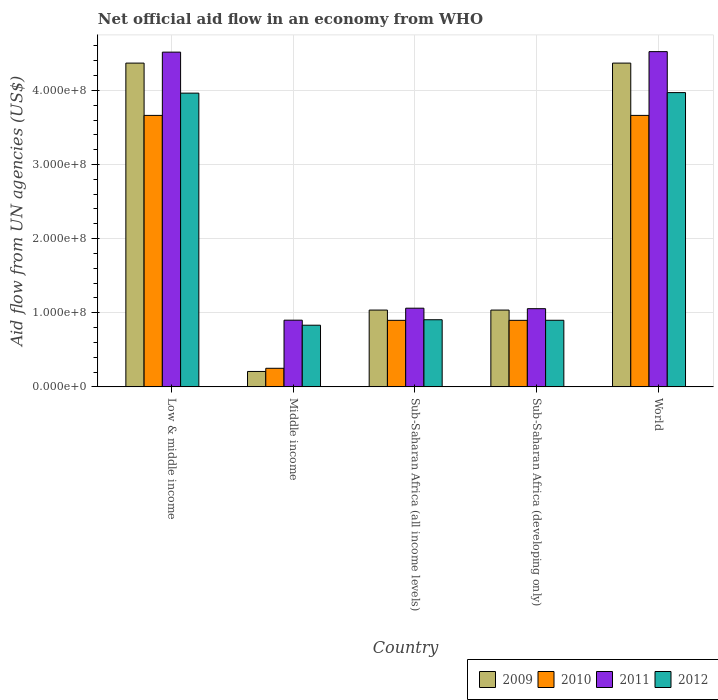How many different coloured bars are there?
Offer a very short reply. 4. Are the number of bars on each tick of the X-axis equal?
Offer a very short reply. Yes. How many bars are there on the 1st tick from the left?
Provide a succinct answer. 4. In how many cases, is the number of bars for a given country not equal to the number of legend labels?
Offer a very short reply. 0. What is the net official aid flow in 2009 in Sub-Saharan Africa (developing only)?
Offer a very short reply. 1.04e+08. Across all countries, what is the maximum net official aid flow in 2009?
Provide a short and direct response. 4.37e+08. Across all countries, what is the minimum net official aid flow in 2011?
Give a very brief answer. 9.00e+07. In which country was the net official aid flow in 2011 minimum?
Offer a very short reply. Middle income. What is the total net official aid flow in 2010 in the graph?
Provide a succinct answer. 9.37e+08. What is the difference between the net official aid flow in 2012 in Low & middle income and that in Middle income?
Keep it short and to the point. 3.13e+08. What is the difference between the net official aid flow in 2009 in Sub-Saharan Africa (developing only) and the net official aid flow in 2010 in World?
Offer a very short reply. -2.63e+08. What is the average net official aid flow in 2011 per country?
Your answer should be compact. 2.41e+08. In how many countries, is the net official aid flow in 2010 greater than 20000000 US$?
Offer a very short reply. 5. What is the ratio of the net official aid flow in 2010 in Middle income to that in World?
Your answer should be very brief. 0.07. Is the net official aid flow in 2009 in Low & middle income less than that in Middle income?
Offer a very short reply. No. Is the difference between the net official aid flow in 2012 in Low & middle income and Middle income greater than the difference between the net official aid flow in 2010 in Low & middle income and Middle income?
Ensure brevity in your answer.  No. What is the difference between the highest and the second highest net official aid flow in 2011?
Your answer should be compact. 3.46e+08. What is the difference between the highest and the lowest net official aid flow in 2011?
Ensure brevity in your answer.  3.62e+08. Is the sum of the net official aid flow in 2010 in Low & middle income and World greater than the maximum net official aid flow in 2011 across all countries?
Ensure brevity in your answer.  Yes. What does the 1st bar from the left in Sub-Saharan Africa (all income levels) represents?
Offer a very short reply. 2009. What does the 1st bar from the right in Middle income represents?
Make the answer very short. 2012. Is it the case that in every country, the sum of the net official aid flow in 2010 and net official aid flow in 2009 is greater than the net official aid flow in 2011?
Give a very brief answer. No. How many bars are there?
Your response must be concise. 20. Are all the bars in the graph horizontal?
Give a very brief answer. No. What is the difference between two consecutive major ticks on the Y-axis?
Provide a short and direct response. 1.00e+08. Where does the legend appear in the graph?
Your answer should be very brief. Bottom right. How many legend labels are there?
Offer a very short reply. 4. What is the title of the graph?
Give a very brief answer. Net official aid flow in an economy from WHO. Does "1984" appear as one of the legend labels in the graph?
Keep it short and to the point. No. What is the label or title of the Y-axis?
Your answer should be compact. Aid flow from UN agencies (US$). What is the Aid flow from UN agencies (US$) of 2009 in Low & middle income?
Offer a terse response. 4.37e+08. What is the Aid flow from UN agencies (US$) in 2010 in Low & middle income?
Provide a short and direct response. 3.66e+08. What is the Aid flow from UN agencies (US$) in 2011 in Low & middle income?
Ensure brevity in your answer.  4.52e+08. What is the Aid flow from UN agencies (US$) in 2012 in Low & middle income?
Provide a succinct answer. 3.96e+08. What is the Aid flow from UN agencies (US$) of 2009 in Middle income?
Give a very brief answer. 2.08e+07. What is the Aid flow from UN agencies (US$) of 2010 in Middle income?
Your answer should be very brief. 2.51e+07. What is the Aid flow from UN agencies (US$) of 2011 in Middle income?
Your answer should be compact. 9.00e+07. What is the Aid flow from UN agencies (US$) of 2012 in Middle income?
Provide a succinct answer. 8.32e+07. What is the Aid flow from UN agencies (US$) in 2009 in Sub-Saharan Africa (all income levels)?
Offer a very short reply. 1.04e+08. What is the Aid flow from UN agencies (US$) of 2010 in Sub-Saharan Africa (all income levels)?
Offer a very short reply. 8.98e+07. What is the Aid flow from UN agencies (US$) of 2011 in Sub-Saharan Africa (all income levels)?
Provide a succinct answer. 1.06e+08. What is the Aid flow from UN agencies (US$) in 2012 in Sub-Saharan Africa (all income levels)?
Offer a terse response. 9.06e+07. What is the Aid flow from UN agencies (US$) of 2009 in Sub-Saharan Africa (developing only)?
Your answer should be compact. 1.04e+08. What is the Aid flow from UN agencies (US$) in 2010 in Sub-Saharan Africa (developing only)?
Give a very brief answer. 8.98e+07. What is the Aid flow from UN agencies (US$) of 2011 in Sub-Saharan Africa (developing only)?
Ensure brevity in your answer.  1.05e+08. What is the Aid flow from UN agencies (US$) in 2012 in Sub-Saharan Africa (developing only)?
Make the answer very short. 8.98e+07. What is the Aid flow from UN agencies (US$) of 2009 in World?
Ensure brevity in your answer.  4.37e+08. What is the Aid flow from UN agencies (US$) in 2010 in World?
Keep it short and to the point. 3.66e+08. What is the Aid flow from UN agencies (US$) in 2011 in World?
Your answer should be very brief. 4.52e+08. What is the Aid flow from UN agencies (US$) of 2012 in World?
Ensure brevity in your answer.  3.97e+08. Across all countries, what is the maximum Aid flow from UN agencies (US$) of 2009?
Ensure brevity in your answer.  4.37e+08. Across all countries, what is the maximum Aid flow from UN agencies (US$) in 2010?
Give a very brief answer. 3.66e+08. Across all countries, what is the maximum Aid flow from UN agencies (US$) in 2011?
Ensure brevity in your answer.  4.52e+08. Across all countries, what is the maximum Aid flow from UN agencies (US$) of 2012?
Provide a succinct answer. 3.97e+08. Across all countries, what is the minimum Aid flow from UN agencies (US$) of 2009?
Provide a short and direct response. 2.08e+07. Across all countries, what is the minimum Aid flow from UN agencies (US$) of 2010?
Give a very brief answer. 2.51e+07. Across all countries, what is the minimum Aid flow from UN agencies (US$) of 2011?
Provide a succinct answer. 9.00e+07. Across all countries, what is the minimum Aid flow from UN agencies (US$) of 2012?
Ensure brevity in your answer.  8.32e+07. What is the total Aid flow from UN agencies (US$) in 2009 in the graph?
Provide a succinct answer. 1.10e+09. What is the total Aid flow from UN agencies (US$) in 2010 in the graph?
Offer a very short reply. 9.37e+08. What is the total Aid flow from UN agencies (US$) of 2011 in the graph?
Your response must be concise. 1.21e+09. What is the total Aid flow from UN agencies (US$) in 2012 in the graph?
Your response must be concise. 1.06e+09. What is the difference between the Aid flow from UN agencies (US$) in 2009 in Low & middle income and that in Middle income?
Give a very brief answer. 4.16e+08. What is the difference between the Aid flow from UN agencies (US$) in 2010 in Low & middle income and that in Middle income?
Your answer should be compact. 3.41e+08. What is the difference between the Aid flow from UN agencies (US$) in 2011 in Low & middle income and that in Middle income?
Offer a very short reply. 3.62e+08. What is the difference between the Aid flow from UN agencies (US$) of 2012 in Low & middle income and that in Middle income?
Provide a succinct answer. 3.13e+08. What is the difference between the Aid flow from UN agencies (US$) of 2009 in Low & middle income and that in Sub-Saharan Africa (all income levels)?
Offer a terse response. 3.33e+08. What is the difference between the Aid flow from UN agencies (US$) in 2010 in Low & middle income and that in Sub-Saharan Africa (all income levels)?
Ensure brevity in your answer.  2.76e+08. What is the difference between the Aid flow from UN agencies (US$) in 2011 in Low & middle income and that in Sub-Saharan Africa (all income levels)?
Your answer should be compact. 3.45e+08. What is the difference between the Aid flow from UN agencies (US$) in 2012 in Low & middle income and that in Sub-Saharan Africa (all income levels)?
Provide a succinct answer. 3.06e+08. What is the difference between the Aid flow from UN agencies (US$) in 2009 in Low & middle income and that in Sub-Saharan Africa (developing only)?
Make the answer very short. 3.33e+08. What is the difference between the Aid flow from UN agencies (US$) of 2010 in Low & middle income and that in Sub-Saharan Africa (developing only)?
Offer a very short reply. 2.76e+08. What is the difference between the Aid flow from UN agencies (US$) in 2011 in Low & middle income and that in Sub-Saharan Africa (developing only)?
Your answer should be compact. 3.46e+08. What is the difference between the Aid flow from UN agencies (US$) of 2012 in Low & middle income and that in Sub-Saharan Africa (developing only)?
Make the answer very short. 3.06e+08. What is the difference between the Aid flow from UN agencies (US$) in 2009 in Low & middle income and that in World?
Ensure brevity in your answer.  0. What is the difference between the Aid flow from UN agencies (US$) in 2010 in Low & middle income and that in World?
Give a very brief answer. 0. What is the difference between the Aid flow from UN agencies (US$) in 2011 in Low & middle income and that in World?
Your answer should be very brief. -6.70e+05. What is the difference between the Aid flow from UN agencies (US$) in 2012 in Low & middle income and that in World?
Offer a terse response. -7.20e+05. What is the difference between the Aid flow from UN agencies (US$) of 2009 in Middle income and that in Sub-Saharan Africa (all income levels)?
Your response must be concise. -8.28e+07. What is the difference between the Aid flow from UN agencies (US$) of 2010 in Middle income and that in Sub-Saharan Africa (all income levels)?
Offer a very short reply. -6.47e+07. What is the difference between the Aid flow from UN agencies (US$) of 2011 in Middle income and that in Sub-Saharan Africa (all income levels)?
Provide a short and direct response. -1.62e+07. What is the difference between the Aid flow from UN agencies (US$) of 2012 in Middle income and that in Sub-Saharan Africa (all income levels)?
Give a very brief answer. -7.39e+06. What is the difference between the Aid flow from UN agencies (US$) of 2009 in Middle income and that in Sub-Saharan Africa (developing only)?
Your answer should be very brief. -8.28e+07. What is the difference between the Aid flow from UN agencies (US$) in 2010 in Middle income and that in Sub-Saharan Africa (developing only)?
Your answer should be very brief. -6.47e+07. What is the difference between the Aid flow from UN agencies (US$) of 2011 in Middle income and that in Sub-Saharan Africa (developing only)?
Give a very brief answer. -1.55e+07. What is the difference between the Aid flow from UN agencies (US$) in 2012 in Middle income and that in Sub-Saharan Africa (developing only)?
Provide a short and direct response. -6.67e+06. What is the difference between the Aid flow from UN agencies (US$) of 2009 in Middle income and that in World?
Keep it short and to the point. -4.16e+08. What is the difference between the Aid flow from UN agencies (US$) in 2010 in Middle income and that in World?
Make the answer very short. -3.41e+08. What is the difference between the Aid flow from UN agencies (US$) in 2011 in Middle income and that in World?
Your answer should be compact. -3.62e+08. What is the difference between the Aid flow from UN agencies (US$) in 2012 in Middle income and that in World?
Your answer should be very brief. -3.14e+08. What is the difference between the Aid flow from UN agencies (US$) in 2011 in Sub-Saharan Africa (all income levels) and that in Sub-Saharan Africa (developing only)?
Your answer should be very brief. 6.70e+05. What is the difference between the Aid flow from UN agencies (US$) in 2012 in Sub-Saharan Africa (all income levels) and that in Sub-Saharan Africa (developing only)?
Provide a short and direct response. 7.20e+05. What is the difference between the Aid flow from UN agencies (US$) in 2009 in Sub-Saharan Africa (all income levels) and that in World?
Give a very brief answer. -3.33e+08. What is the difference between the Aid flow from UN agencies (US$) in 2010 in Sub-Saharan Africa (all income levels) and that in World?
Your answer should be compact. -2.76e+08. What is the difference between the Aid flow from UN agencies (US$) in 2011 in Sub-Saharan Africa (all income levels) and that in World?
Make the answer very short. -3.46e+08. What is the difference between the Aid flow from UN agencies (US$) of 2012 in Sub-Saharan Africa (all income levels) and that in World?
Your answer should be compact. -3.06e+08. What is the difference between the Aid flow from UN agencies (US$) of 2009 in Sub-Saharan Africa (developing only) and that in World?
Offer a terse response. -3.33e+08. What is the difference between the Aid flow from UN agencies (US$) of 2010 in Sub-Saharan Africa (developing only) and that in World?
Your answer should be compact. -2.76e+08. What is the difference between the Aid flow from UN agencies (US$) in 2011 in Sub-Saharan Africa (developing only) and that in World?
Keep it short and to the point. -3.47e+08. What is the difference between the Aid flow from UN agencies (US$) of 2012 in Sub-Saharan Africa (developing only) and that in World?
Your answer should be very brief. -3.07e+08. What is the difference between the Aid flow from UN agencies (US$) of 2009 in Low & middle income and the Aid flow from UN agencies (US$) of 2010 in Middle income?
Provide a short and direct response. 4.12e+08. What is the difference between the Aid flow from UN agencies (US$) of 2009 in Low & middle income and the Aid flow from UN agencies (US$) of 2011 in Middle income?
Make the answer very short. 3.47e+08. What is the difference between the Aid flow from UN agencies (US$) in 2009 in Low & middle income and the Aid flow from UN agencies (US$) in 2012 in Middle income?
Your answer should be compact. 3.54e+08. What is the difference between the Aid flow from UN agencies (US$) of 2010 in Low & middle income and the Aid flow from UN agencies (US$) of 2011 in Middle income?
Make the answer very short. 2.76e+08. What is the difference between the Aid flow from UN agencies (US$) in 2010 in Low & middle income and the Aid flow from UN agencies (US$) in 2012 in Middle income?
Give a very brief answer. 2.83e+08. What is the difference between the Aid flow from UN agencies (US$) of 2011 in Low & middle income and the Aid flow from UN agencies (US$) of 2012 in Middle income?
Your response must be concise. 3.68e+08. What is the difference between the Aid flow from UN agencies (US$) in 2009 in Low & middle income and the Aid flow from UN agencies (US$) in 2010 in Sub-Saharan Africa (all income levels)?
Ensure brevity in your answer.  3.47e+08. What is the difference between the Aid flow from UN agencies (US$) of 2009 in Low & middle income and the Aid flow from UN agencies (US$) of 2011 in Sub-Saharan Africa (all income levels)?
Ensure brevity in your answer.  3.31e+08. What is the difference between the Aid flow from UN agencies (US$) of 2009 in Low & middle income and the Aid flow from UN agencies (US$) of 2012 in Sub-Saharan Africa (all income levels)?
Your answer should be compact. 3.46e+08. What is the difference between the Aid flow from UN agencies (US$) of 2010 in Low & middle income and the Aid flow from UN agencies (US$) of 2011 in Sub-Saharan Africa (all income levels)?
Make the answer very short. 2.60e+08. What is the difference between the Aid flow from UN agencies (US$) of 2010 in Low & middle income and the Aid flow from UN agencies (US$) of 2012 in Sub-Saharan Africa (all income levels)?
Your answer should be very brief. 2.76e+08. What is the difference between the Aid flow from UN agencies (US$) of 2011 in Low & middle income and the Aid flow from UN agencies (US$) of 2012 in Sub-Saharan Africa (all income levels)?
Provide a succinct answer. 3.61e+08. What is the difference between the Aid flow from UN agencies (US$) of 2009 in Low & middle income and the Aid flow from UN agencies (US$) of 2010 in Sub-Saharan Africa (developing only)?
Offer a terse response. 3.47e+08. What is the difference between the Aid flow from UN agencies (US$) in 2009 in Low & middle income and the Aid flow from UN agencies (US$) in 2011 in Sub-Saharan Africa (developing only)?
Ensure brevity in your answer.  3.31e+08. What is the difference between the Aid flow from UN agencies (US$) in 2009 in Low & middle income and the Aid flow from UN agencies (US$) in 2012 in Sub-Saharan Africa (developing only)?
Make the answer very short. 3.47e+08. What is the difference between the Aid flow from UN agencies (US$) in 2010 in Low & middle income and the Aid flow from UN agencies (US$) in 2011 in Sub-Saharan Africa (developing only)?
Your answer should be compact. 2.61e+08. What is the difference between the Aid flow from UN agencies (US$) in 2010 in Low & middle income and the Aid flow from UN agencies (US$) in 2012 in Sub-Saharan Africa (developing only)?
Make the answer very short. 2.76e+08. What is the difference between the Aid flow from UN agencies (US$) in 2011 in Low & middle income and the Aid flow from UN agencies (US$) in 2012 in Sub-Saharan Africa (developing only)?
Provide a succinct answer. 3.62e+08. What is the difference between the Aid flow from UN agencies (US$) of 2009 in Low & middle income and the Aid flow from UN agencies (US$) of 2010 in World?
Offer a very short reply. 7.06e+07. What is the difference between the Aid flow from UN agencies (US$) in 2009 in Low & middle income and the Aid flow from UN agencies (US$) in 2011 in World?
Offer a terse response. -1.55e+07. What is the difference between the Aid flow from UN agencies (US$) in 2009 in Low & middle income and the Aid flow from UN agencies (US$) in 2012 in World?
Your answer should be compact. 3.98e+07. What is the difference between the Aid flow from UN agencies (US$) of 2010 in Low & middle income and the Aid flow from UN agencies (US$) of 2011 in World?
Give a very brief answer. -8.60e+07. What is the difference between the Aid flow from UN agencies (US$) of 2010 in Low & middle income and the Aid flow from UN agencies (US$) of 2012 in World?
Keep it short and to the point. -3.08e+07. What is the difference between the Aid flow from UN agencies (US$) in 2011 in Low & middle income and the Aid flow from UN agencies (US$) in 2012 in World?
Provide a succinct answer. 5.46e+07. What is the difference between the Aid flow from UN agencies (US$) in 2009 in Middle income and the Aid flow from UN agencies (US$) in 2010 in Sub-Saharan Africa (all income levels)?
Provide a short and direct response. -6.90e+07. What is the difference between the Aid flow from UN agencies (US$) of 2009 in Middle income and the Aid flow from UN agencies (US$) of 2011 in Sub-Saharan Africa (all income levels)?
Your answer should be compact. -8.54e+07. What is the difference between the Aid flow from UN agencies (US$) of 2009 in Middle income and the Aid flow from UN agencies (US$) of 2012 in Sub-Saharan Africa (all income levels)?
Offer a terse response. -6.98e+07. What is the difference between the Aid flow from UN agencies (US$) of 2010 in Middle income and the Aid flow from UN agencies (US$) of 2011 in Sub-Saharan Africa (all income levels)?
Provide a short and direct response. -8.11e+07. What is the difference between the Aid flow from UN agencies (US$) in 2010 in Middle income and the Aid flow from UN agencies (US$) in 2012 in Sub-Saharan Africa (all income levels)?
Provide a succinct answer. -6.55e+07. What is the difference between the Aid flow from UN agencies (US$) of 2011 in Middle income and the Aid flow from UN agencies (US$) of 2012 in Sub-Saharan Africa (all income levels)?
Ensure brevity in your answer.  -5.90e+05. What is the difference between the Aid flow from UN agencies (US$) of 2009 in Middle income and the Aid flow from UN agencies (US$) of 2010 in Sub-Saharan Africa (developing only)?
Your answer should be compact. -6.90e+07. What is the difference between the Aid flow from UN agencies (US$) in 2009 in Middle income and the Aid flow from UN agencies (US$) in 2011 in Sub-Saharan Africa (developing only)?
Provide a short and direct response. -8.47e+07. What is the difference between the Aid flow from UN agencies (US$) of 2009 in Middle income and the Aid flow from UN agencies (US$) of 2012 in Sub-Saharan Africa (developing only)?
Your response must be concise. -6.90e+07. What is the difference between the Aid flow from UN agencies (US$) of 2010 in Middle income and the Aid flow from UN agencies (US$) of 2011 in Sub-Saharan Africa (developing only)?
Provide a short and direct response. -8.04e+07. What is the difference between the Aid flow from UN agencies (US$) of 2010 in Middle income and the Aid flow from UN agencies (US$) of 2012 in Sub-Saharan Africa (developing only)?
Your answer should be very brief. -6.48e+07. What is the difference between the Aid flow from UN agencies (US$) in 2011 in Middle income and the Aid flow from UN agencies (US$) in 2012 in Sub-Saharan Africa (developing only)?
Make the answer very short. 1.30e+05. What is the difference between the Aid flow from UN agencies (US$) of 2009 in Middle income and the Aid flow from UN agencies (US$) of 2010 in World?
Your response must be concise. -3.45e+08. What is the difference between the Aid flow from UN agencies (US$) of 2009 in Middle income and the Aid flow from UN agencies (US$) of 2011 in World?
Give a very brief answer. -4.31e+08. What is the difference between the Aid flow from UN agencies (US$) of 2009 in Middle income and the Aid flow from UN agencies (US$) of 2012 in World?
Ensure brevity in your answer.  -3.76e+08. What is the difference between the Aid flow from UN agencies (US$) of 2010 in Middle income and the Aid flow from UN agencies (US$) of 2011 in World?
Provide a short and direct response. -4.27e+08. What is the difference between the Aid flow from UN agencies (US$) in 2010 in Middle income and the Aid flow from UN agencies (US$) in 2012 in World?
Provide a short and direct response. -3.72e+08. What is the difference between the Aid flow from UN agencies (US$) in 2011 in Middle income and the Aid flow from UN agencies (US$) in 2012 in World?
Make the answer very short. -3.07e+08. What is the difference between the Aid flow from UN agencies (US$) in 2009 in Sub-Saharan Africa (all income levels) and the Aid flow from UN agencies (US$) in 2010 in Sub-Saharan Africa (developing only)?
Your answer should be very brief. 1.39e+07. What is the difference between the Aid flow from UN agencies (US$) in 2009 in Sub-Saharan Africa (all income levels) and the Aid flow from UN agencies (US$) in 2011 in Sub-Saharan Africa (developing only)?
Provide a short and direct response. -1.86e+06. What is the difference between the Aid flow from UN agencies (US$) of 2009 in Sub-Saharan Africa (all income levels) and the Aid flow from UN agencies (US$) of 2012 in Sub-Saharan Africa (developing only)?
Keep it short and to the point. 1.38e+07. What is the difference between the Aid flow from UN agencies (US$) in 2010 in Sub-Saharan Africa (all income levels) and the Aid flow from UN agencies (US$) in 2011 in Sub-Saharan Africa (developing only)?
Your response must be concise. -1.57e+07. What is the difference between the Aid flow from UN agencies (US$) of 2010 in Sub-Saharan Africa (all income levels) and the Aid flow from UN agencies (US$) of 2012 in Sub-Saharan Africa (developing only)?
Make the answer very short. -9.00e+04. What is the difference between the Aid flow from UN agencies (US$) of 2011 in Sub-Saharan Africa (all income levels) and the Aid flow from UN agencies (US$) of 2012 in Sub-Saharan Africa (developing only)?
Keep it short and to the point. 1.63e+07. What is the difference between the Aid flow from UN agencies (US$) in 2009 in Sub-Saharan Africa (all income levels) and the Aid flow from UN agencies (US$) in 2010 in World?
Ensure brevity in your answer.  -2.63e+08. What is the difference between the Aid flow from UN agencies (US$) of 2009 in Sub-Saharan Africa (all income levels) and the Aid flow from UN agencies (US$) of 2011 in World?
Offer a terse response. -3.49e+08. What is the difference between the Aid flow from UN agencies (US$) in 2009 in Sub-Saharan Africa (all income levels) and the Aid flow from UN agencies (US$) in 2012 in World?
Make the answer very short. -2.93e+08. What is the difference between the Aid flow from UN agencies (US$) of 2010 in Sub-Saharan Africa (all income levels) and the Aid flow from UN agencies (US$) of 2011 in World?
Keep it short and to the point. -3.62e+08. What is the difference between the Aid flow from UN agencies (US$) of 2010 in Sub-Saharan Africa (all income levels) and the Aid flow from UN agencies (US$) of 2012 in World?
Offer a very short reply. -3.07e+08. What is the difference between the Aid flow from UN agencies (US$) in 2011 in Sub-Saharan Africa (all income levels) and the Aid flow from UN agencies (US$) in 2012 in World?
Keep it short and to the point. -2.91e+08. What is the difference between the Aid flow from UN agencies (US$) of 2009 in Sub-Saharan Africa (developing only) and the Aid flow from UN agencies (US$) of 2010 in World?
Provide a short and direct response. -2.63e+08. What is the difference between the Aid flow from UN agencies (US$) of 2009 in Sub-Saharan Africa (developing only) and the Aid flow from UN agencies (US$) of 2011 in World?
Offer a terse response. -3.49e+08. What is the difference between the Aid flow from UN agencies (US$) in 2009 in Sub-Saharan Africa (developing only) and the Aid flow from UN agencies (US$) in 2012 in World?
Your answer should be very brief. -2.93e+08. What is the difference between the Aid flow from UN agencies (US$) of 2010 in Sub-Saharan Africa (developing only) and the Aid flow from UN agencies (US$) of 2011 in World?
Offer a very short reply. -3.62e+08. What is the difference between the Aid flow from UN agencies (US$) in 2010 in Sub-Saharan Africa (developing only) and the Aid flow from UN agencies (US$) in 2012 in World?
Provide a succinct answer. -3.07e+08. What is the difference between the Aid flow from UN agencies (US$) of 2011 in Sub-Saharan Africa (developing only) and the Aid flow from UN agencies (US$) of 2012 in World?
Ensure brevity in your answer.  -2.92e+08. What is the average Aid flow from UN agencies (US$) of 2009 per country?
Provide a short and direct response. 2.20e+08. What is the average Aid flow from UN agencies (US$) in 2010 per country?
Give a very brief answer. 1.87e+08. What is the average Aid flow from UN agencies (US$) of 2011 per country?
Ensure brevity in your answer.  2.41e+08. What is the average Aid flow from UN agencies (US$) in 2012 per country?
Provide a succinct answer. 2.11e+08. What is the difference between the Aid flow from UN agencies (US$) of 2009 and Aid flow from UN agencies (US$) of 2010 in Low & middle income?
Provide a succinct answer. 7.06e+07. What is the difference between the Aid flow from UN agencies (US$) of 2009 and Aid flow from UN agencies (US$) of 2011 in Low & middle income?
Offer a very short reply. -1.48e+07. What is the difference between the Aid flow from UN agencies (US$) in 2009 and Aid flow from UN agencies (US$) in 2012 in Low & middle income?
Your answer should be very brief. 4.05e+07. What is the difference between the Aid flow from UN agencies (US$) of 2010 and Aid flow from UN agencies (US$) of 2011 in Low & middle income?
Provide a short and direct response. -8.54e+07. What is the difference between the Aid flow from UN agencies (US$) of 2010 and Aid flow from UN agencies (US$) of 2012 in Low & middle income?
Provide a succinct answer. -3.00e+07. What is the difference between the Aid flow from UN agencies (US$) of 2011 and Aid flow from UN agencies (US$) of 2012 in Low & middle income?
Provide a short and direct response. 5.53e+07. What is the difference between the Aid flow from UN agencies (US$) in 2009 and Aid flow from UN agencies (US$) in 2010 in Middle income?
Offer a very short reply. -4.27e+06. What is the difference between the Aid flow from UN agencies (US$) in 2009 and Aid flow from UN agencies (US$) in 2011 in Middle income?
Provide a succinct answer. -6.92e+07. What is the difference between the Aid flow from UN agencies (US$) in 2009 and Aid flow from UN agencies (US$) in 2012 in Middle income?
Make the answer very short. -6.24e+07. What is the difference between the Aid flow from UN agencies (US$) of 2010 and Aid flow from UN agencies (US$) of 2011 in Middle income?
Your answer should be very brief. -6.49e+07. What is the difference between the Aid flow from UN agencies (US$) in 2010 and Aid flow from UN agencies (US$) in 2012 in Middle income?
Offer a very short reply. -5.81e+07. What is the difference between the Aid flow from UN agencies (US$) in 2011 and Aid flow from UN agencies (US$) in 2012 in Middle income?
Your answer should be compact. 6.80e+06. What is the difference between the Aid flow from UN agencies (US$) of 2009 and Aid flow from UN agencies (US$) of 2010 in Sub-Saharan Africa (all income levels)?
Your answer should be very brief. 1.39e+07. What is the difference between the Aid flow from UN agencies (US$) of 2009 and Aid flow from UN agencies (US$) of 2011 in Sub-Saharan Africa (all income levels)?
Keep it short and to the point. -2.53e+06. What is the difference between the Aid flow from UN agencies (US$) in 2009 and Aid flow from UN agencies (US$) in 2012 in Sub-Saharan Africa (all income levels)?
Your response must be concise. 1.30e+07. What is the difference between the Aid flow from UN agencies (US$) in 2010 and Aid flow from UN agencies (US$) in 2011 in Sub-Saharan Africa (all income levels)?
Give a very brief answer. -1.64e+07. What is the difference between the Aid flow from UN agencies (US$) in 2010 and Aid flow from UN agencies (US$) in 2012 in Sub-Saharan Africa (all income levels)?
Your answer should be compact. -8.10e+05. What is the difference between the Aid flow from UN agencies (US$) of 2011 and Aid flow from UN agencies (US$) of 2012 in Sub-Saharan Africa (all income levels)?
Provide a short and direct response. 1.56e+07. What is the difference between the Aid flow from UN agencies (US$) of 2009 and Aid flow from UN agencies (US$) of 2010 in Sub-Saharan Africa (developing only)?
Offer a terse response. 1.39e+07. What is the difference between the Aid flow from UN agencies (US$) of 2009 and Aid flow from UN agencies (US$) of 2011 in Sub-Saharan Africa (developing only)?
Make the answer very short. -1.86e+06. What is the difference between the Aid flow from UN agencies (US$) in 2009 and Aid flow from UN agencies (US$) in 2012 in Sub-Saharan Africa (developing only)?
Offer a very short reply. 1.38e+07. What is the difference between the Aid flow from UN agencies (US$) in 2010 and Aid flow from UN agencies (US$) in 2011 in Sub-Saharan Africa (developing only)?
Offer a very short reply. -1.57e+07. What is the difference between the Aid flow from UN agencies (US$) of 2010 and Aid flow from UN agencies (US$) of 2012 in Sub-Saharan Africa (developing only)?
Your answer should be very brief. -9.00e+04. What is the difference between the Aid flow from UN agencies (US$) in 2011 and Aid flow from UN agencies (US$) in 2012 in Sub-Saharan Africa (developing only)?
Ensure brevity in your answer.  1.56e+07. What is the difference between the Aid flow from UN agencies (US$) of 2009 and Aid flow from UN agencies (US$) of 2010 in World?
Offer a very short reply. 7.06e+07. What is the difference between the Aid flow from UN agencies (US$) of 2009 and Aid flow from UN agencies (US$) of 2011 in World?
Provide a succinct answer. -1.55e+07. What is the difference between the Aid flow from UN agencies (US$) of 2009 and Aid flow from UN agencies (US$) of 2012 in World?
Give a very brief answer. 3.98e+07. What is the difference between the Aid flow from UN agencies (US$) of 2010 and Aid flow from UN agencies (US$) of 2011 in World?
Keep it short and to the point. -8.60e+07. What is the difference between the Aid flow from UN agencies (US$) in 2010 and Aid flow from UN agencies (US$) in 2012 in World?
Your answer should be compact. -3.08e+07. What is the difference between the Aid flow from UN agencies (US$) in 2011 and Aid flow from UN agencies (US$) in 2012 in World?
Ensure brevity in your answer.  5.53e+07. What is the ratio of the Aid flow from UN agencies (US$) of 2009 in Low & middle income to that in Middle income?
Provide a succinct answer. 21. What is the ratio of the Aid flow from UN agencies (US$) in 2010 in Low & middle income to that in Middle income?
Offer a terse response. 14.61. What is the ratio of the Aid flow from UN agencies (US$) of 2011 in Low & middle income to that in Middle income?
Offer a very short reply. 5.02. What is the ratio of the Aid flow from UN agencies (US$) of 2012 in Low & middle income to that in Middle income?
Your answer should be very brief. 4.76. What is the ratio of the Aid flow from UN agencies (US$) of 2009 in Low & middle income to that in Sub-Saharan Africa (all income levels)?
Offer a terse response. 4.22. What is the ratio of the Aid flow from UN agencies (US$) in 2010 in Low & middle income to that in Sub-Saharan Africa (all income levels)?
Provide a succinct answer. 4.08. What is the ratio of the Aid flow from UN agencies (US$) in 2011 in Low & middle income to that in Sub-Saharan Africa (all income levels)?
Give a very brief answer. 4.25. What is the ratio of the Aid flow from UN agencies (US$) in 2012 in Low & middle income to that in Sub-Saharan Africa (all income levels)?
Keep it short and to the point. 4.38. What is the ratio of the Aid flow from UN agencies (US$) of 2009 in Low & middle income to that in Sub-Saharan Africa (developing only)?
Give a very brief answer. 4.22. What is the ratio of the Aid flow from UN agencies (US$) in 2010 in Low & middle income to that in Sub-Saharan Africa (developing only)?
Provide a succinct answer. 4.08. What is the ratio of the Aid flow from UN agencies (US$) in 2011 in Low & middle income to that in Sub-Saharan Africa (developing only)?
Provide a succinct answer. 4.28. What is the ratio of the Aid flow from UN agencies (US$) of 2012 in Low & middle income to that in Sub-Saharan Africa (developing only)?
Make the answer very short. 4.41. What is the ratio of the Aid flow from UN agencies (US$) in 2009 in Middle income to that in Sub-Saharan Africa (all income levels)?
Ensure brevity in your answer.  0.2. What is the ratio of the Aid flow from UN agencies (US$) of 2010 in Middle income to that in Sub-Saharan Africa (all income levels)?
Provide a succinct answer. 0.28. What is the ratio of the Aid flow from UN agencies (US$) in 2011 in Middle income to that in Sub-Saharan Africa (all income levels)?
Provide a short and direct response. 0.85. What is the ratio of the Aid flow from UN agencies (US$) of 2012 in Middle income to that in Sub-Saharan Africa (all income levels)?
Provide a succinct answer. 0.92. What is the ratio of the Aid flow from UN agencies (US$) of 2009 in Middle income to that in Sub-Saharan Africa (developing only)?
Offer a terse response. 0.2. What is the ratio of the Aid flow from UN agencies (US$) in 2010 in Middle income to that in Sub-Saharan Africa (developing only)?
Your response must be concise. 0.28. What is the ratio of the Aid flow from UN agencies (US$) in 2011 in Middle income to that in Sub-Saharan Africa (developing only)?
Your response must be concise. 0.85. What is the ratio of the Aid flow from UN agencies (US$) of 2012 in Middle income to that in Sub-Saharan Africa (developing only)?
Offer a very short reply. 0.93. What is the ratio of the Aid flow from UN agencies (US$) in 2009 in Middle income to that in World?
Your answer should be compact. 0.05. What is the ratio of the Aid flow from UN agencies (US$) of 2010 in Middle income to that in World?
Make the answer very short. 0.07. What is the ratio of the Aid flow from UN agencies (US$) in 2011 in Middle income to that in World?
Provide a succinct answer. 0.2. What is the ratio of the Aid flow from UN agencies (US$) of 2012 in Middle income to that in World?
Give a very brief answer. 0.21. What is the ratio of the Aid flow from UN agencies (US$) in 2010 in Sub-Saharan Africa (all income levels) to that in Sub-Saharan Africa (developing only)?
Provide a succinct answer. 1. What is the ratio of the Aid flow from UN agencies (US$) of 2011 in Sub-Saharan Africa (all income levels) to that in Sub-Saharan Africa (developing only)?
Your response must be concise. 1.01. What is the ratio of the Aid flow from UN agencies (US$) of 2012 in Sub-Saharan Africa (all income levels) to that in Sub-Saharan Africa (developing only)?
Your answer should be compact. 1.01. What is the ratio of the Aid flow from UN agencies (US$) of 2009 in Sub-Saharan Africa (all income levels) to that in World?
Your answer should be compact. 0.24. What is the ratio of the Aid flow from UN agencies (US$) in 2010 in Sub-Saharan Africa (all income levels) to that in World?
Your answer should be compact. 0.25. What is the ratio of the Aid flow from UN agencies (US$) of 2011 in Sub-Saharan Africa (all income levels) to that in World?
Give a very brief answer. 0.23. What is the ratio of the Aid flow from UN agencies (US$) in 2012 in Sub-Saharan Africa (all income levels) to that in World?
Make the answer very short. 0.23. What is the ratio of the Aid flow from UN agencies (US$) in 2009 in Sub-Saharan Africa (developing only) to that in World?
Offer a very short reply. 0.24. What is the ratio of the Aid flow from UN agencies (US$) in 2010 in Sub-Saharan Africa (developing only) to that in World?
Make the answer very short. 0.25. What is the ratio of the Aid flow from UN agencies (US$) in 2011 in Sub-Saharan Africa (developing only) to that in World?
Provide a succinct answer. 0.23. What is the ratio of the Aid flow from UN agencies (US$) of 2012 in Sub-Saharan Africa (developing only) to that in World?
Give a very brief answer. 0.23. What is the difference between the highest and the second highest Aid flow from UN agencies (US$) of 2011?
Provide a short and direct response. 6.70e+05. What is the difference between the highest and the second highest Aid flow from UN agencies (US$) in 2012?
Offer a very short reply. 7.20e+05. What is the difference between the highest and the lowest Aid flow from UN agencies (US$) of 2009?
Your answer should be compact. 4.16e+08. What is the difference between the highest and the lowest Aid flow from UN agencies (US$) in 2010?
Make the answer very short. 3.41e+08. What is the difference between the highest and the lowest Aid flow from UN agencies (US$) in 2011?
Provide a short and direct response. 3.62e+08. What is the difference between the highest and the lowest Aid flow from UN agencies (US$) of 2012?
Make the answer very short. 3.14e+08. 